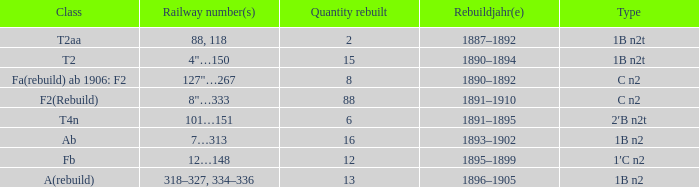What is the total of quantity rebuilt if the type is 1B N2T and the railway number is 88, 118? 1.0. 